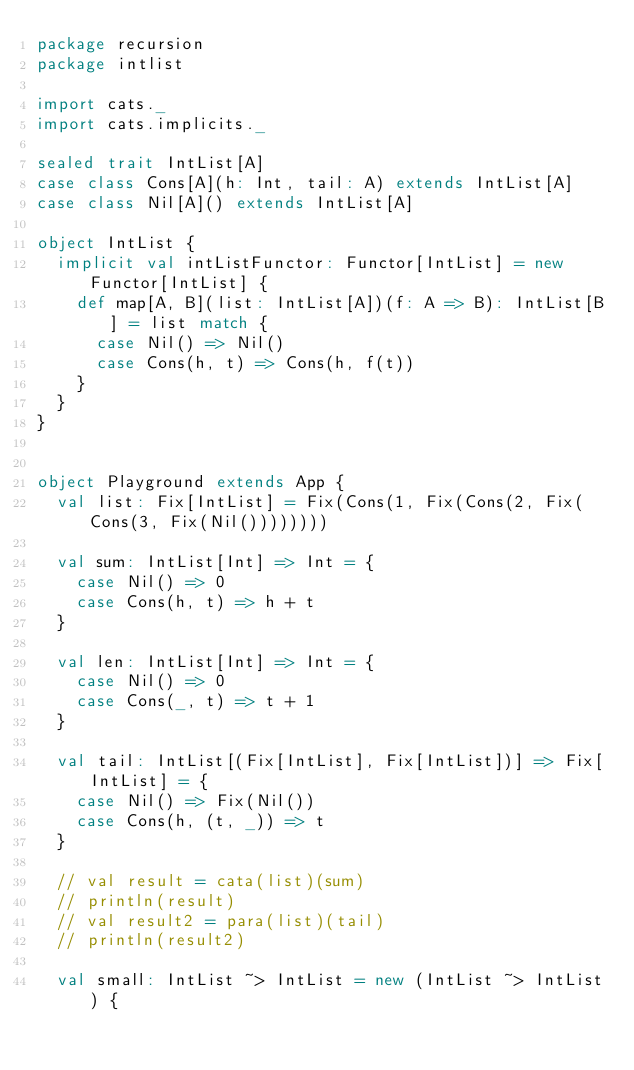Convert code to text. <code><loc_0><loc_0><loc_500><loc_500><_Scala_>package recursion
package intlist

import cats._
import cats.implicits._

sealed trait IntList[A]
case class Cons[A](h: Int, tail: A) extends IntList[A]
case class Nil[A]() extends IntList[A]

object IntList {
  implicit val intListFunctor: Functor[IntList] = new Functor[IntList] {
    def map[A, B](list: IntList[A])(f: A => B): IntList[B] = list match {
      case Nil() => Nil()
      case Cons(h, t) => Cons(h, f(t))
    }
  }
}


object Playground extends App {
  val list: Fix[IntList] = Fix(Cons(1, Fix(Cons(2, Fix(Cons(3, Fix(Nil())))))))

  val sum: IntList[Int] => Int = {
    case Nil() => 0
    case Cons(h, t) => h + t
  }

  val len: IntList[Int] => Int = {
    case Nil() => 0
    case Cons(_, t) => t + 1
  }

  val tail: IntList[(Fix[IntList], Fix[IntList])] => Fix[IntList] = {
    case Nil() => Fix(Nil())
    case Cons(h, (t, _)) => t
  }

  // val result = cata(list)(sum)
  // println(result)
  // val result2 = para(list)(tail)
  // println(result2)

  val small: IntList ~> IntList = new (IntList ~> IntList) {</code> 